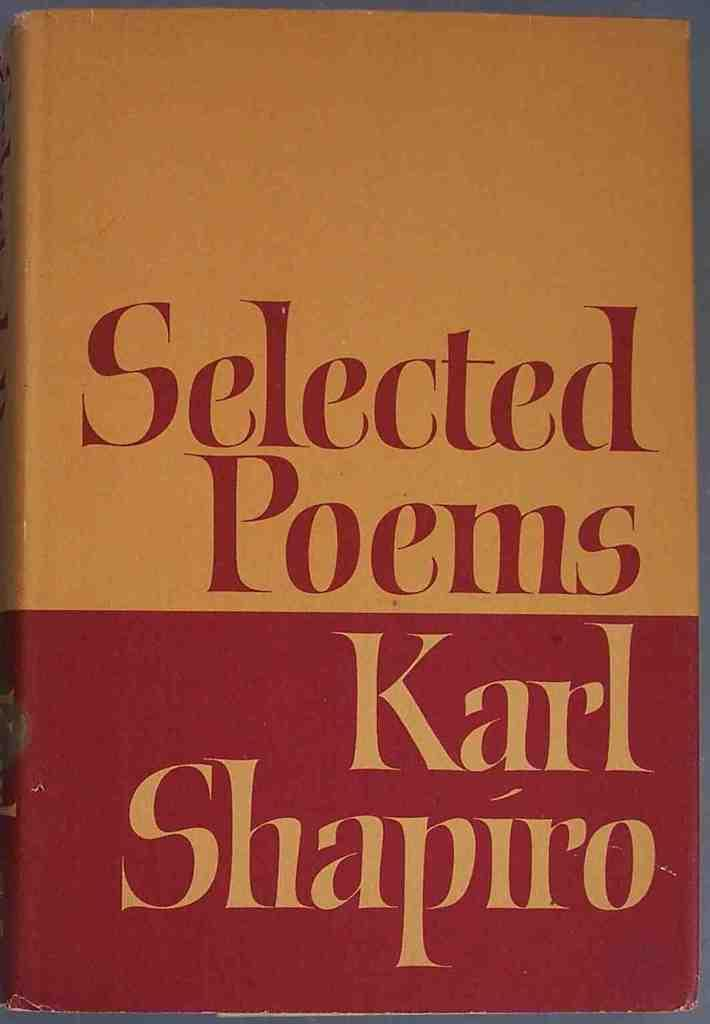<image>
Create a compact narrative representing the image presented. A book of Selected Poems by Karl Shapiro. 